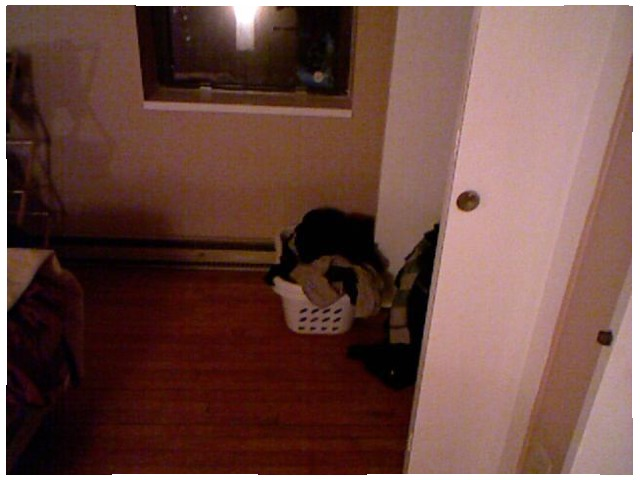<image>
Is there a clothes above the floor? Yes. The clothes is positioned above the floor in the vertical space, higher up in the scene. 